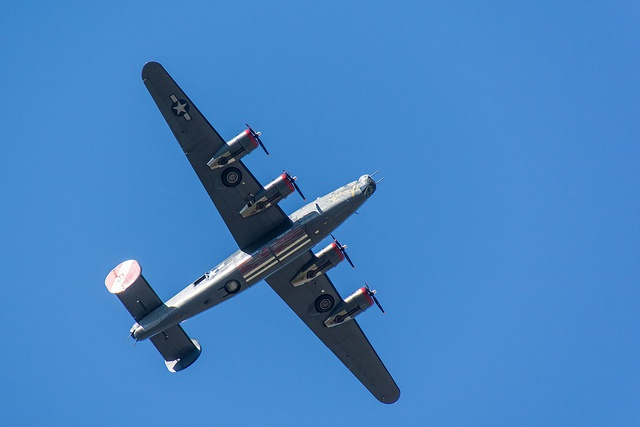Describe the objects in this image and their specific colors. I can see a airplane in gray, black, navy, and lightgray tones in this image. 